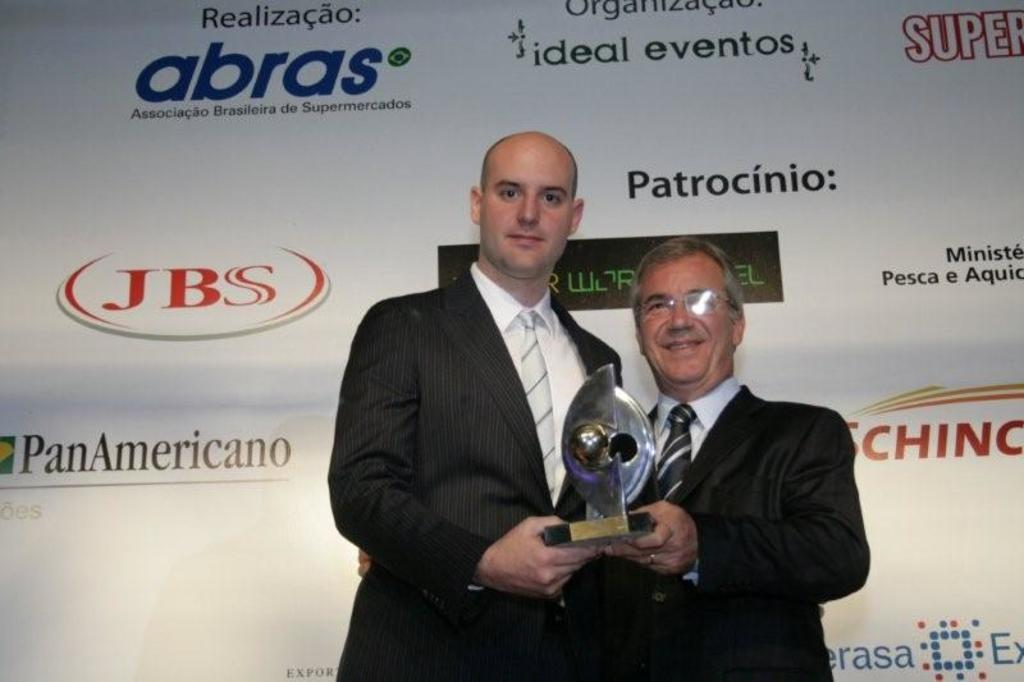How many men are present in the image? There are two men in the image. What are the men wearing? The men are wearing black suits. What are the men holding in the image? The men are holding an award. What is located behind the men in the image? The men are standing in front of a white banner. What type of shock can be seen affecting the letters on the clock in the image? There is no clock or letters present in the image. What type of creature is causing the shock to the letters on the clock in the image? There is no creature or clock present in the image. 